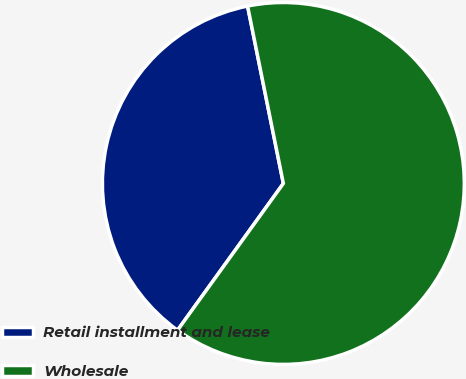<chart> <loc_0><loc_0><loc_500><loc_500><pie_chart><fcel>Retail installment and lease<fcel>Wholesale<nl><fcel>36.89%<fcel>63.11%<nl></chart> 